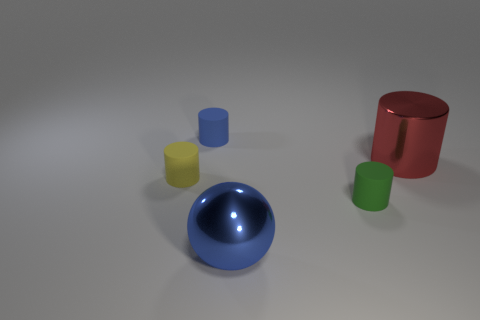What are the colors of the objects in the image? The objects in the image consist of a red cylinder, a blue sphere, a yellow cylinder, and a green cylinder. Is there anything unique about the surface on which these objects are placed? The objects are placed on a neutral, flat surface with a subtle shine that suggests a diffuse reflection, giving the scene a simple and clean look. 